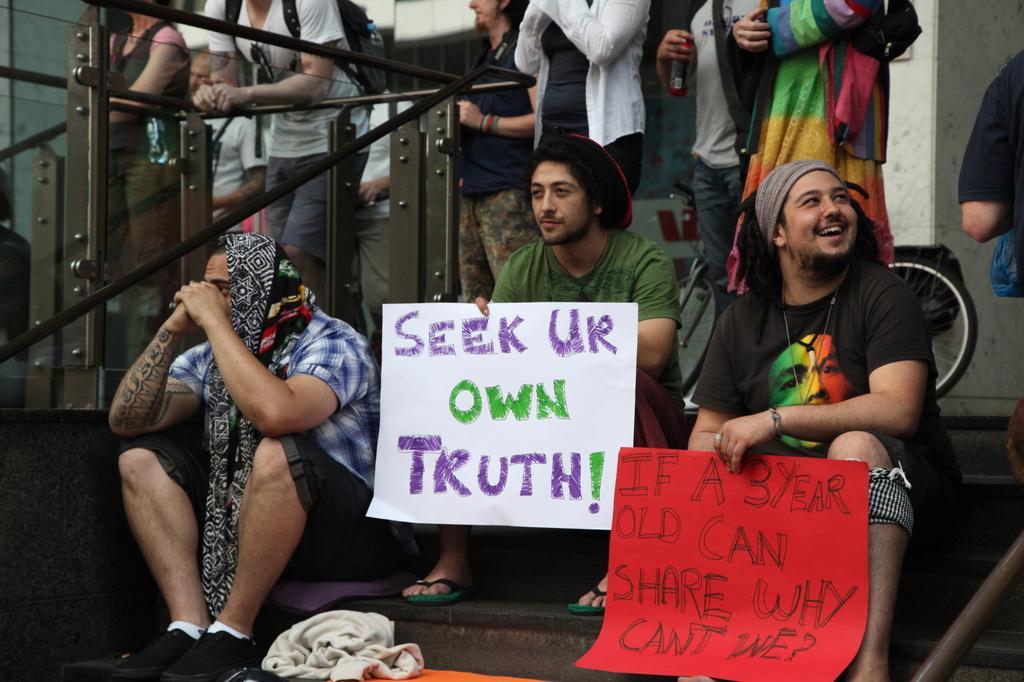Can you describe this image briefly? In this image we can see persons standing on the floor and some are sitting on the chairs by holding papers with some text in their hands. In the background there are railings and walls. 